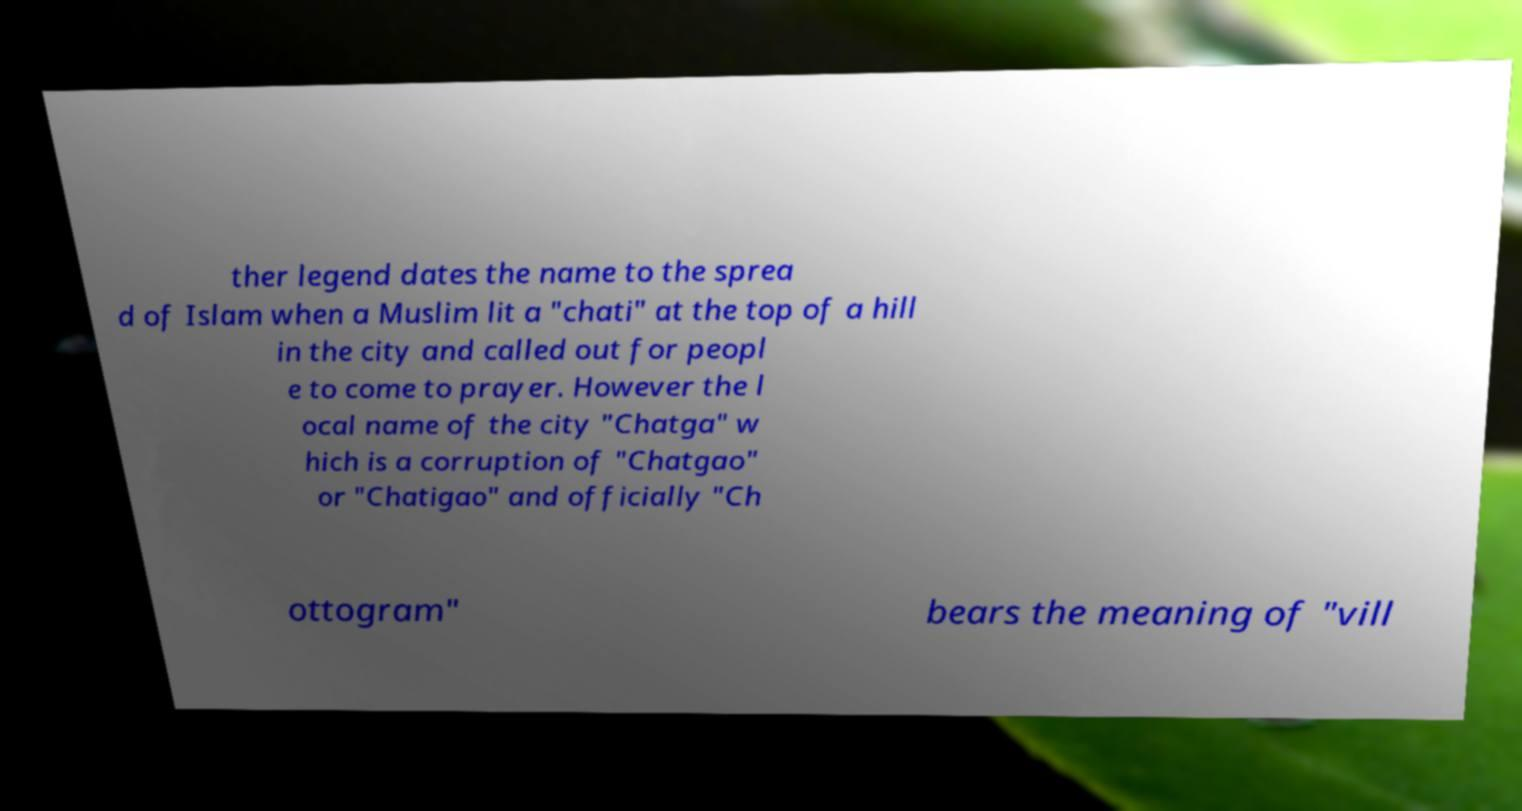What messages or text are displayed in this image? I need them in a readable, typed format. ther legend dates the name to the sprea d of Islam when a Muslim lit a "chati" at the top of a hill in the city and called out for peopl e to come to prayer. However the l ocal name of the city "Chatga" w hich is a corruption of "Chatgao" or "Chatigao" and officially "Ch ottogram" bears the meaning of "vill 